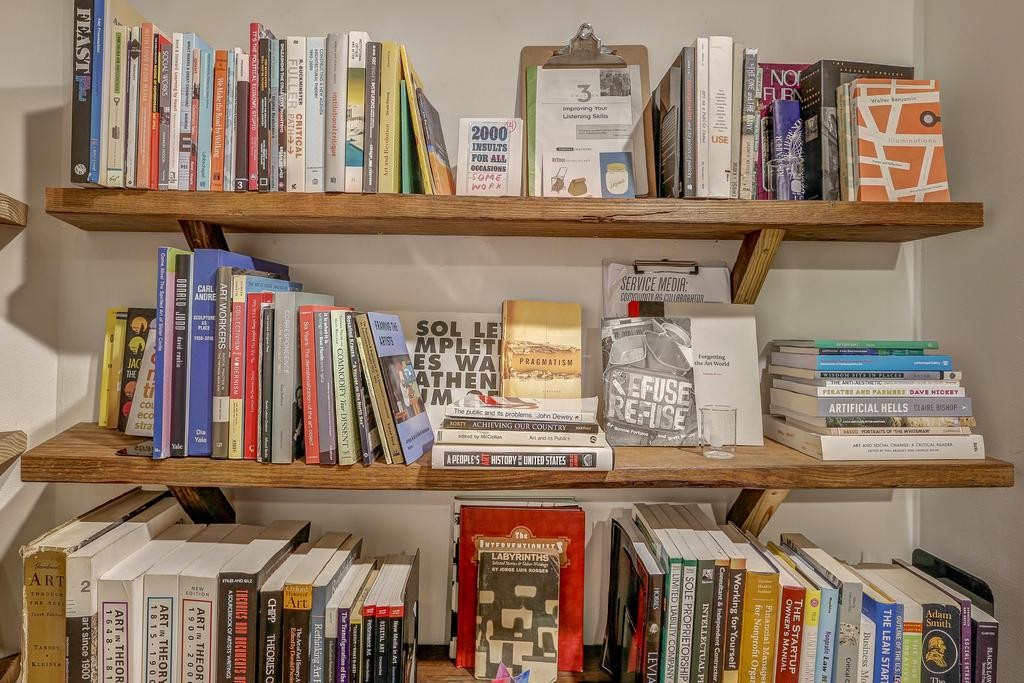<image>
Share a concise interpretation of the image provided. Lots of books are arranged on bookshelves including one titled Pragmatism in the center. 